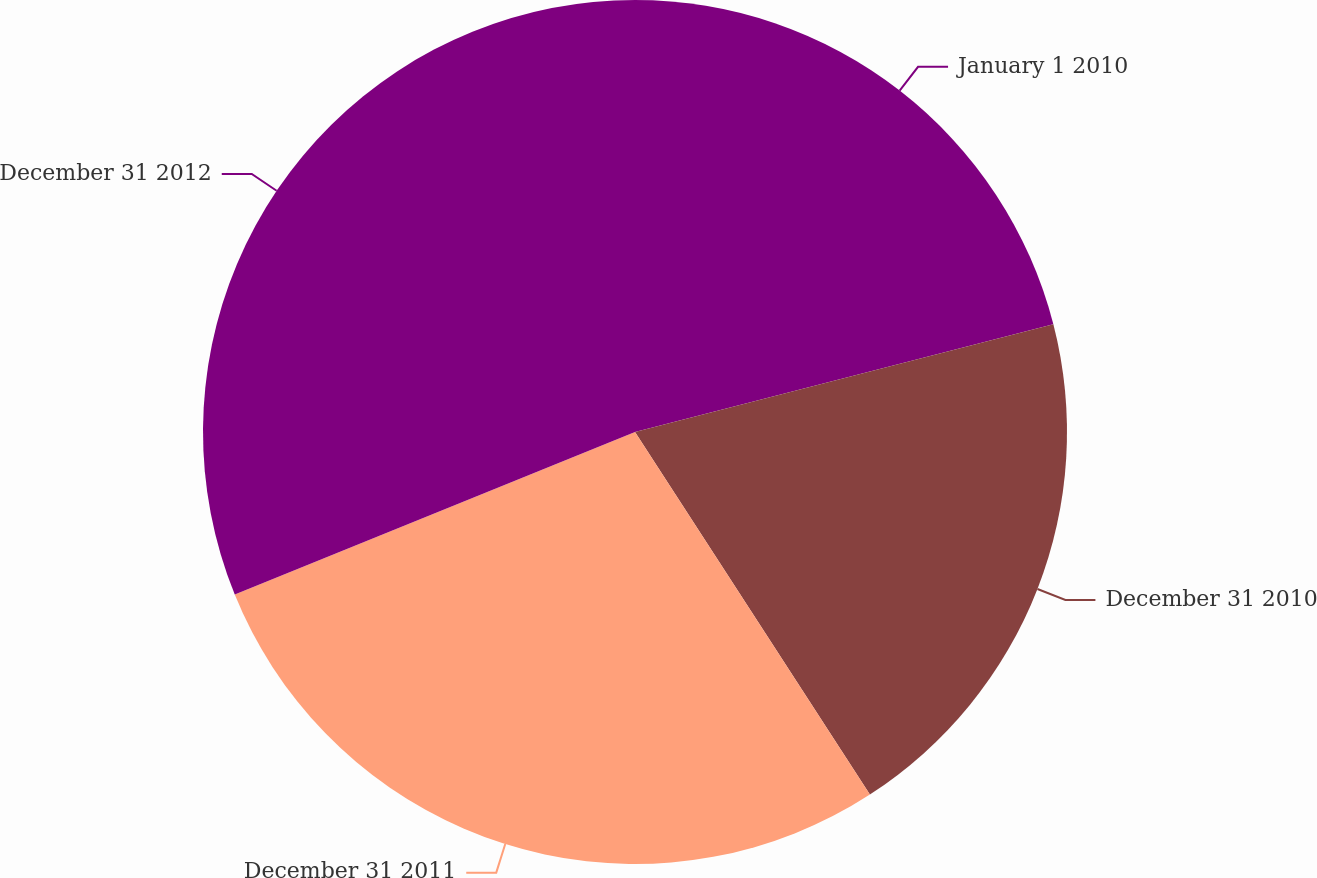<chart> <loc_0><loc_0><loc_500><loc_500><pie_chart><fcel>January 1 2010<fcel>December 31 2010<fcel>December 31 2011<fcel>December 31 2012<nl><fcel>20.99%<fcel>19.86%<fcel>28.01%<fcel>31.14%<nl></chart> 